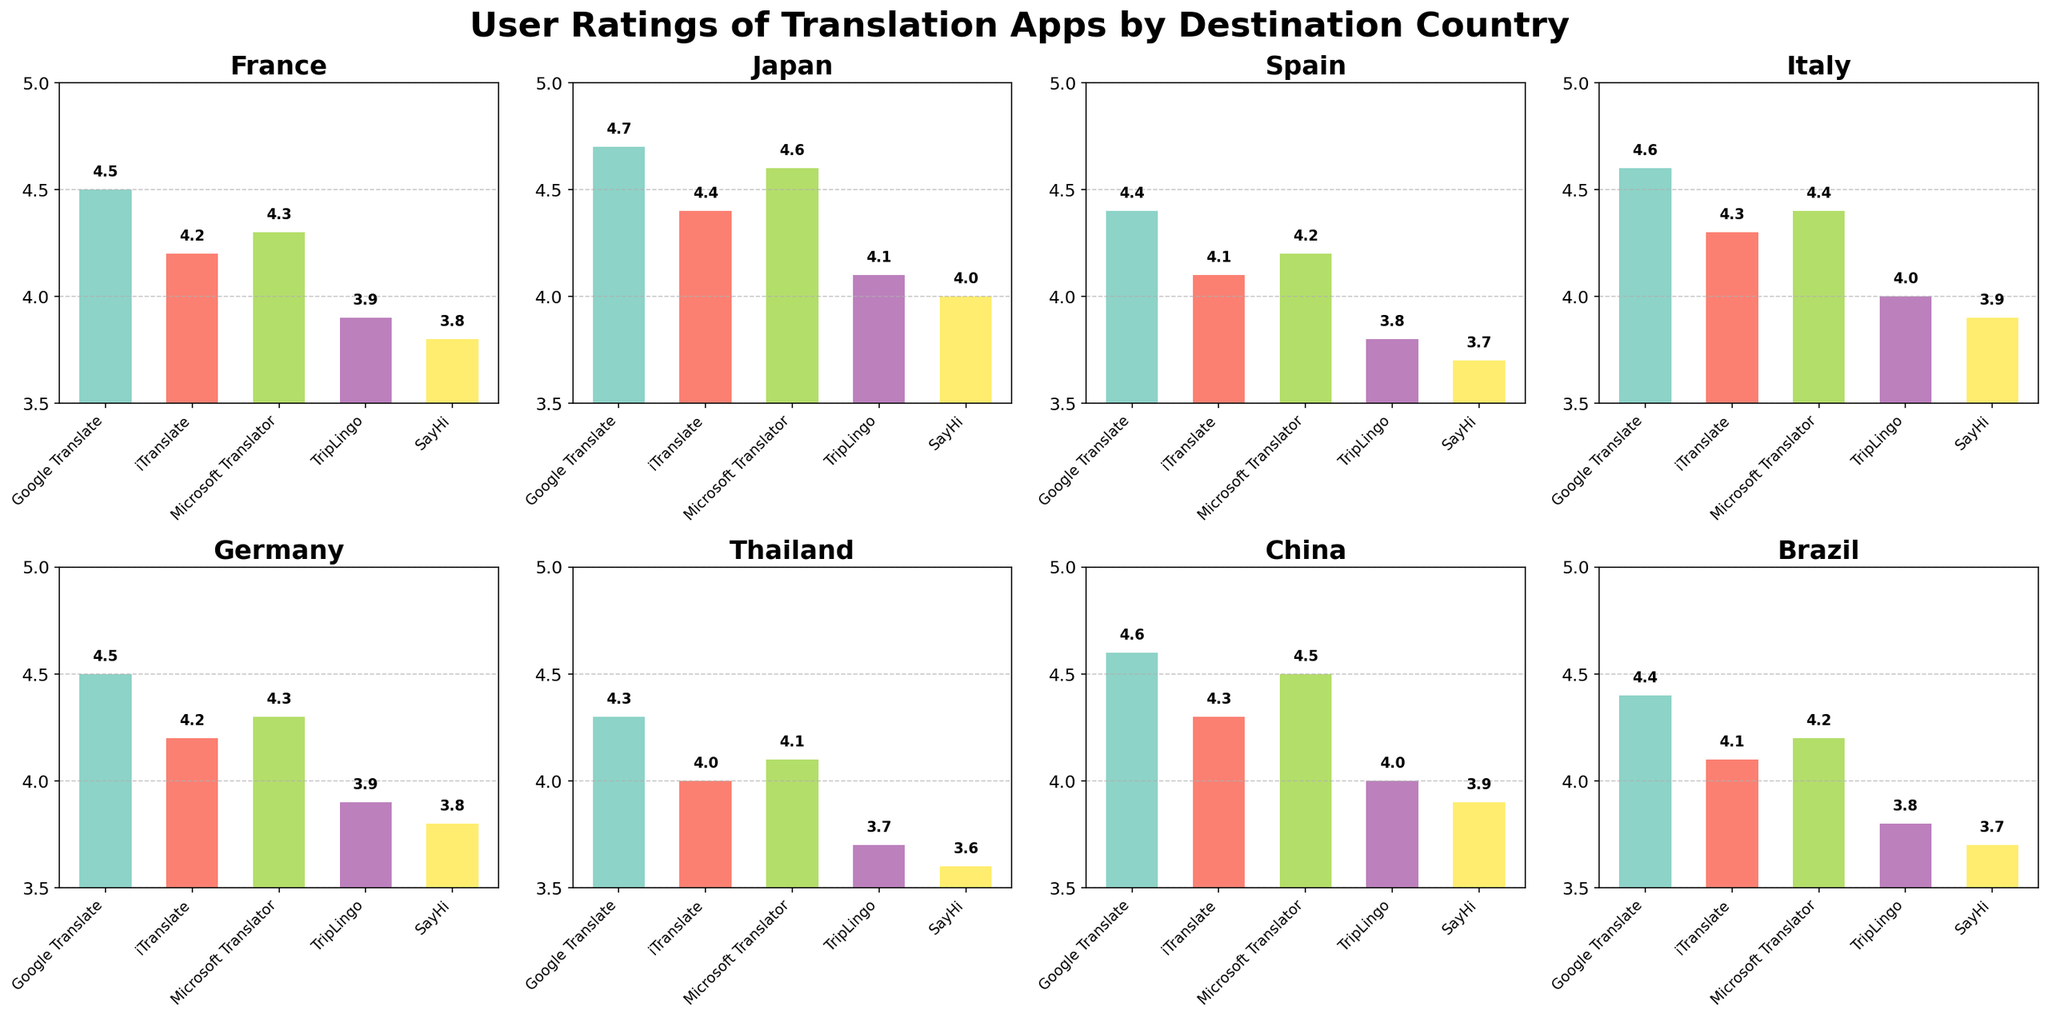what is the title of the figure? The title of the figure is shown at the top, centered.
Answer: User Ratings of Translation Apps by Destination Country How many countries are compared in the figure? The figure has subplots for each country, and there are 8 subplots in total.
Answer: 8 Which app has the highest rating in Japan? Look at the Japan subplot and compare the bar heights for each app; Google Translate has the highest bar.
Answer: Google Translate Which app has the lowest rating in Germany? Look at the Germany subplot and compare the bar heights for each app; SayHi has the lowest bar.
Answer: SayHi What is the average rating of Microsoft Translator across all countries? Add up the ratings of Microsoft Translator for each country and divide by the number of countries: (4.3 + 4.6 + 4.2 + 4.4 + 4.3 + 4.1 + 4.5 + 4.2) / 8 = 34.6 / 8 = 4.325
Answer: 4.3 Which country has the highest average rating for all translation apps? Calculate the average rating for all apps in each country and find the highest: France (4.14), Japan (4.36), Spain (4.04), Italy (4.24), Germany (4.14), Thailand (4.02), China (4.26), Brazil (4.04). Japan has the highest average.
Answer: Japan In how many countries does SayHi have a rating lower than 4? Compare the ratings of SayHi in each subplot: France (3.8), Japan (4.0), Spain (3.7), Italy (3.9), Germany (3.8), Thailand (3.6), China (3.9), Brazil (3.7). SayHi has a rating lower than 4 in 5 countries.
Answer: 5 If you sum the ratings of Google Translate and iTranslate in France and Spain, what is the total? Add the ratings: Google Translate (France: 4.5, Spain: 4.4), iTranslate (France: 4.2, Spain: 4.1). Sum: 4.5 + 4.4 + 4.2 + 4.1 = 17.2
Answer: 17.2 What is the difference between the highest and lowest app ratings in Thailand? Find the highest rating (Google Translate: 4.3) and lowest rating (SayHi: 3.6). Difference: 4.3 - 3.6 = 0.7
Answer: 0.7 